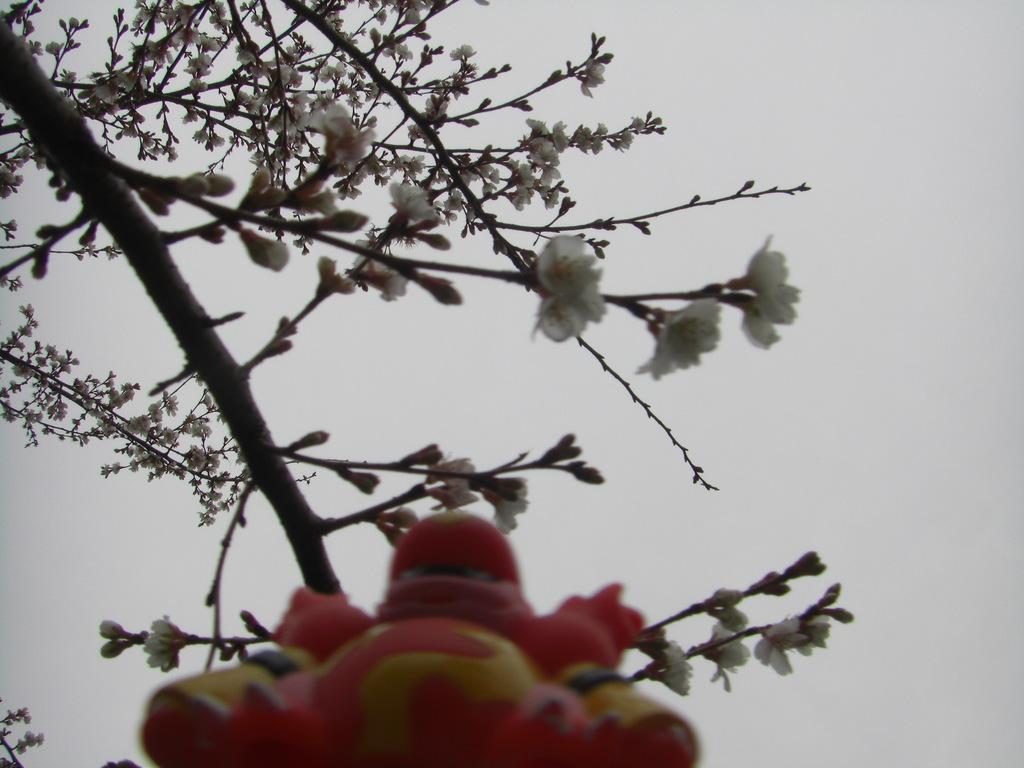Could you give a brief overview of what you see in this image? In this image, we can see a cherry blossom tree and at bottom, there is a toy and in the background, there is sky. 